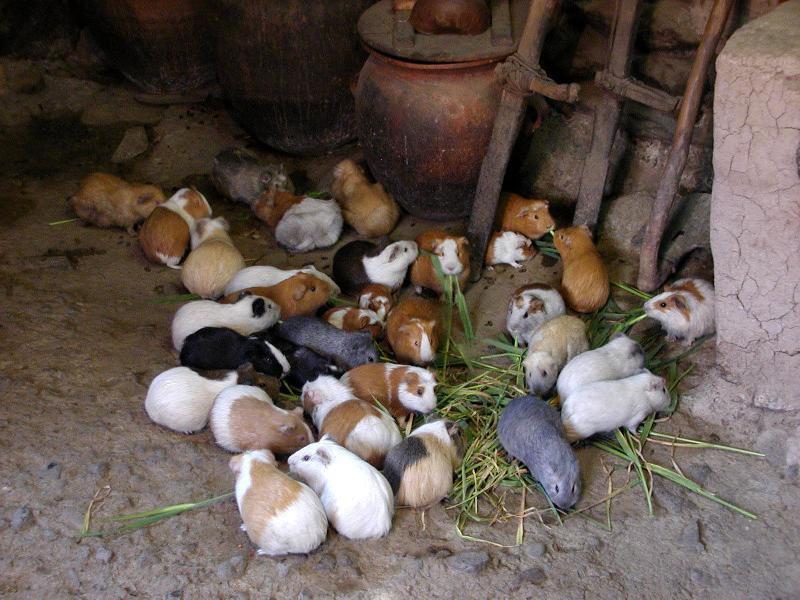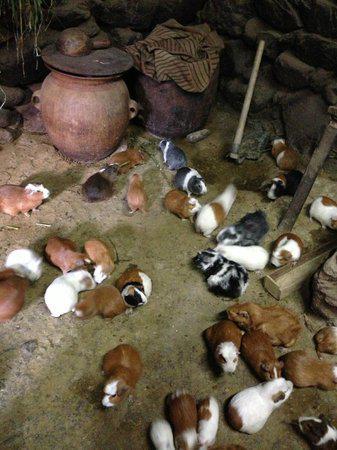The first image is the image on the left, the second image is the image on the right. For the images shown, is this caption "One image shows a little animal with a white nose in a grassy area near some fruit it has been given to eat." true? Answer yes or no. No. The first image is the image on the left, the second image is the image on the right. Analyze the images presented: Is the assertion "One of the images shows exactly two guinea pigs." valid? Answer yes or no. No. The first image is the image on the left, the second image is the image on the right. Considering the images on both sides, is "There is exactly one animal in the image on the left" valid? Answer yes or no. No. 